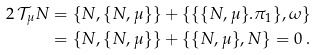Convert formula to latex. <formula><loc_0><loc_0><loc_500><loc_500>2 \, { \mathcal { T } } _ { \mu } N & = \{ N , \{ N , \mu \} \} + \{ \{ \{ N , \mu \} . \pi _ { 1 } \} , \omega \} \\ & = \{ N , \{ N , \mu \} \} + \{ \{ N , \mu \} , N \} = 0 \ .</formula> 